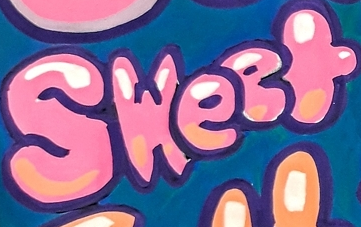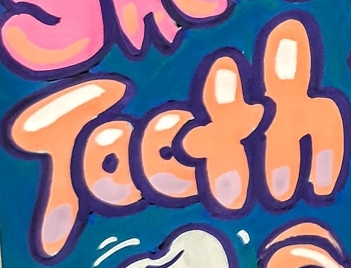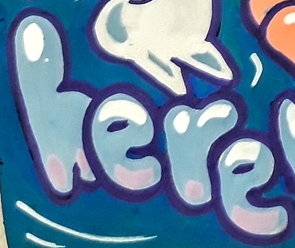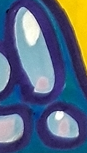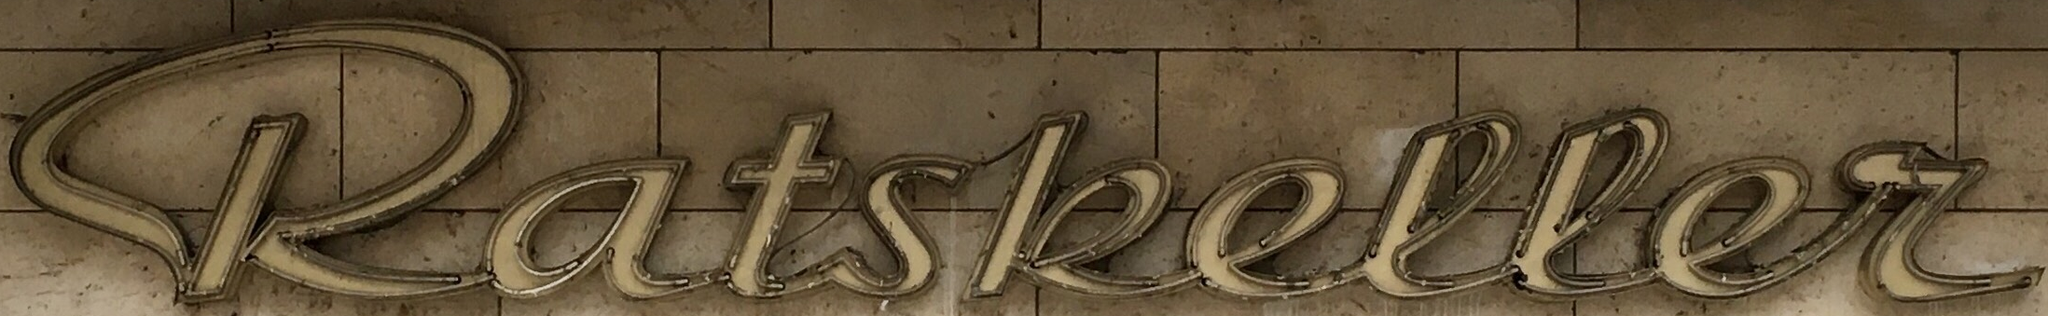Read the text from these images in sequence, separated by a semicolon. Sweet; Tooth; here; !; katskeller 